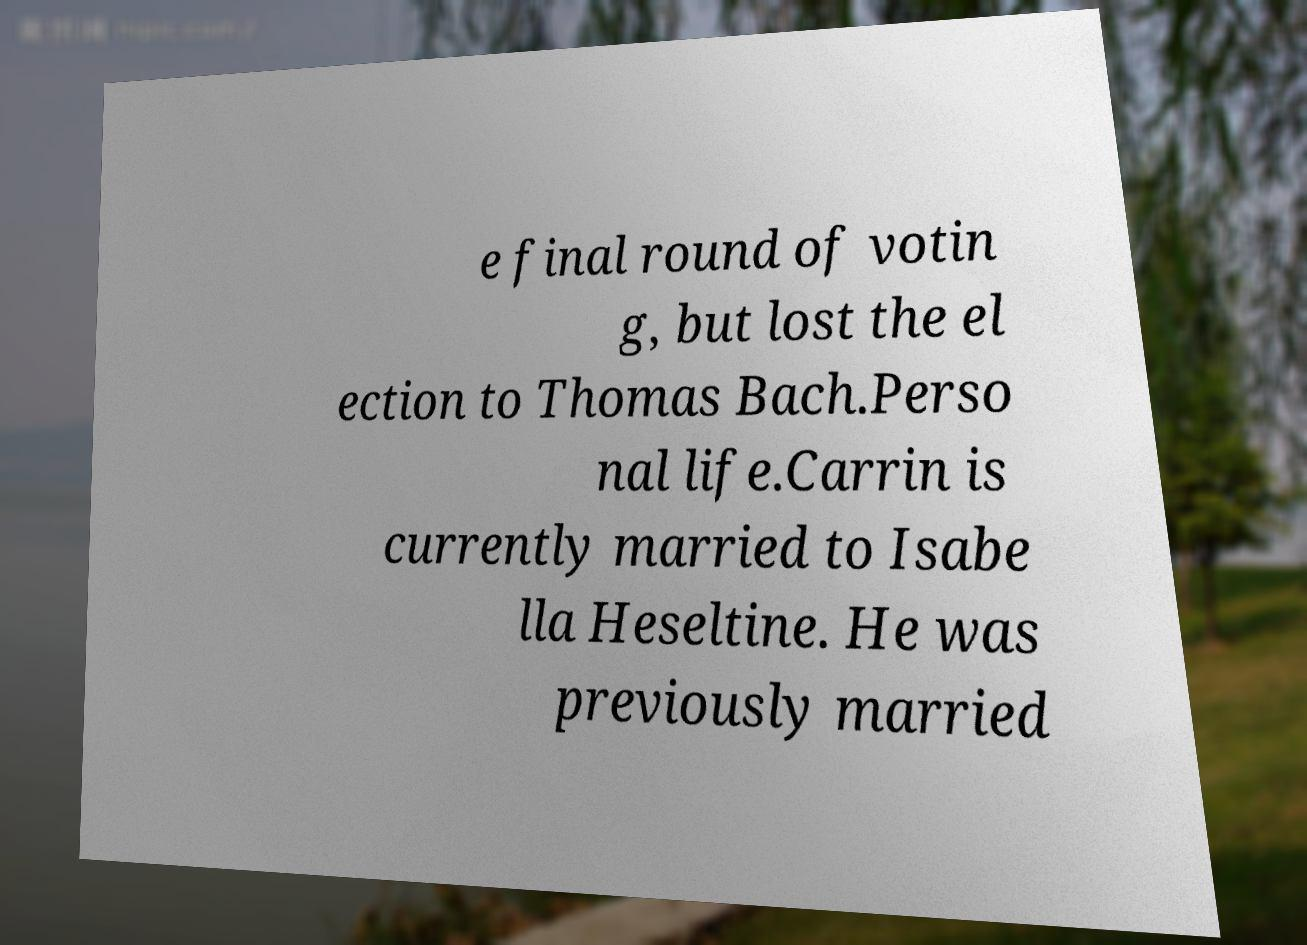For documentation purposes, I need the text within this image transcribed. Could you provide that? e final round of votin g, but lost the el ection to Thomas Bach.Perso nal life.Carrin is currently married to Isabe lla Heseltine. He was previously married 